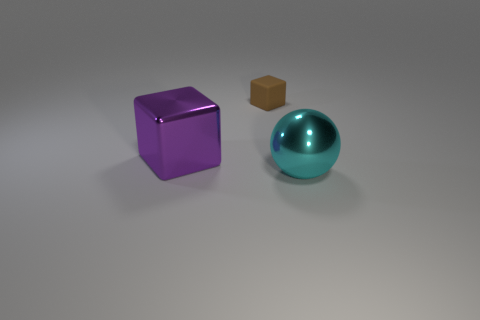Does the small rubber thing have the same shape as the big shiny thing to the left of the tiny brown rubber block?
Keep it short and to the point. Yes. What number of big shiny objects are to the left of the big cyan metal object and right of the brown matte cube?
Offer a very short reply. 0. There is a brown thing that is the same shape as the purple metallic thing; what is it made of?
Offer a very short reply. Rubber. There is a block that is right of the shiny object to the left of the sphere; what is its size?
Your answer should be compact. Small. Are any green matte blocks visible?
Offer a very short reply. No. What is the thing that is on the right side of the purple shiny cube and to the left of the cyan ball made of?
Give a very brief answer. Rubber. Is the number of cyan spheres that are to the right of the purple metallic block greater than the number of small objects on the left side of the brown matte block?
Offer a terse response. Yes. Is there a cube of the same size as the cyan metal sphere?
Give a very brief answer. Yes. There is a brown rubber thing that is behind the large shiny thing on the right side of the shiny object that is to the left of the big cyan object; what is its size?
Provide a short and direct response. Small. The metal ball has what color?
Ensure brevity in your answer.  Cyan. 